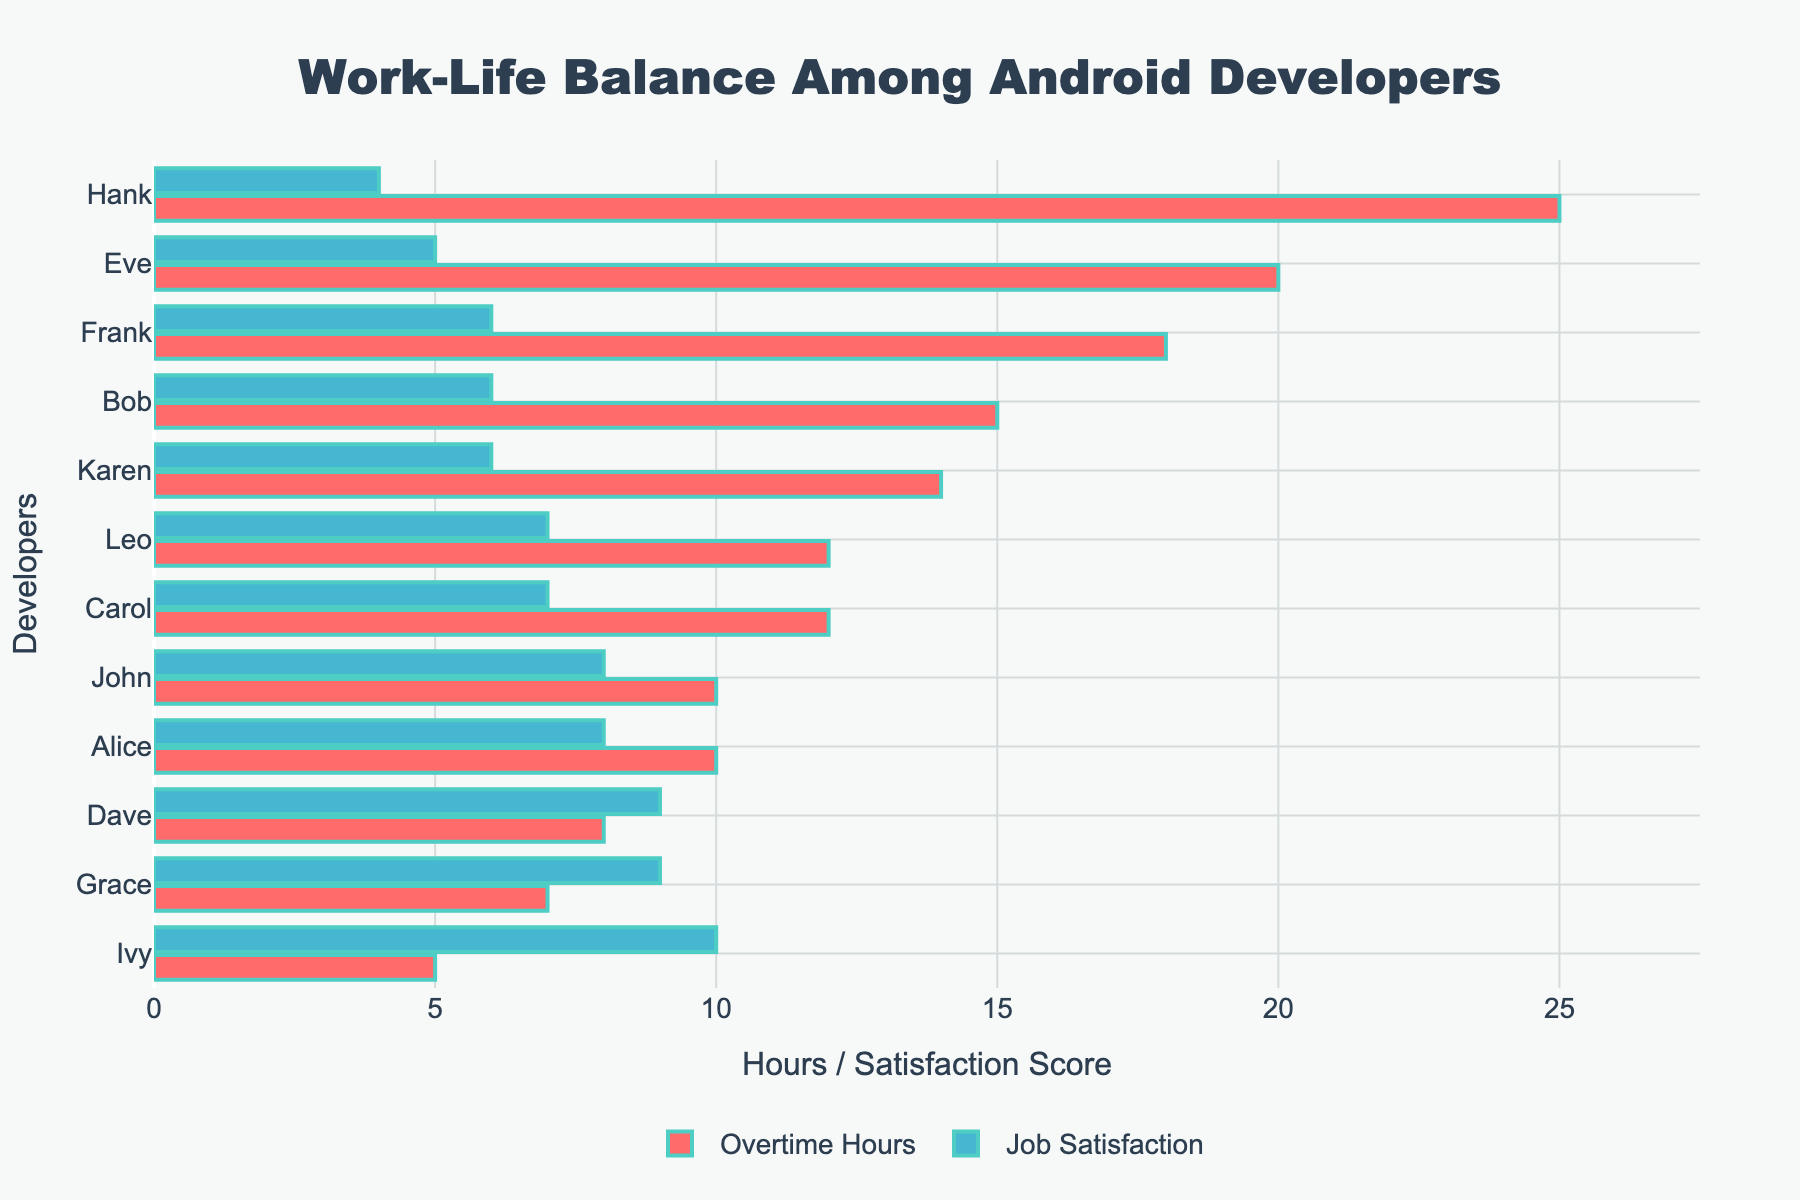What is the average overtime hours worked by the developers? Add up the overtime hours of all developers and divide the total by the number of developers. (10+15+12+8+20+18+7+25+5+10+14+12)/12 = 156/12
Answer: 13 hours Which developer has the highest job satisfaction? Compare the job satisfaction scores of all developers and identify the highest one. Ivy has a job satisfaction score of 10 which is the highest.
Answer: Ivy Who has the lowest job satisfaction and what are their overtime hours? Identify the lowest job satisfaction score and find the corresponding developer and their overtime hours. Hank has the lowest job satisfaction score of 4 and works 25 overtime hours.
Answer: Hank, 25 hours Which developer worked the most overtime hours? Identify the developer with the highest overtime hours in the figure. Hank worked 25 overtime hours.
Answer: Hank Compare Alice and Bob's job satisfaction. Who is more satisfied? Compare Alice's job satisfaction score of 8 with Bob's score of 6. Alice is more satisfied than Bob.
Answer: Alice How much higher is Karen's job satisfaction compared to Eve? Subtract Eve's job satisfaction score from Karen's. 6 - 5 = 1
Answer: 1 What is the median number of overtime hours worked by the developers? List the overtime hours in ascending order (5, 7, 8, 10, 10, 12, 12, 14, 15, 18, 20, 25). The median is the average of the 6th and 7th values: (12+12)/2 = 12.
Answer: 12 hours Is there any developer with both high job satisfaction (>=9) and low overtime hours (<=10)? Look for developers with job satisfaction of 9 or more and overtime hours of 10 or less. Dave has a satisfaction score of 9 and works 8 overtime hours, and Grace has a satisfaction score of 9 and works 7 overtime hours.
Answer: Dave, Grace How many developers have a job satisfaction score of 8? Count the number of developers with a job satisfaction score of 8. Alice and John both have a score of 8.
Answer: 2 developers 